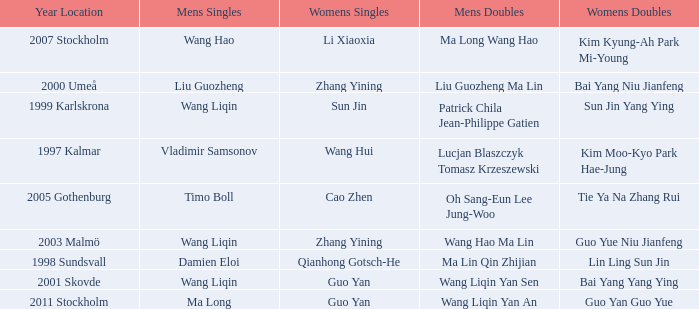What is the place and when was the year when the women's doubles womens were Bai yang Niu Jianfeng? 2000 Umeå. 